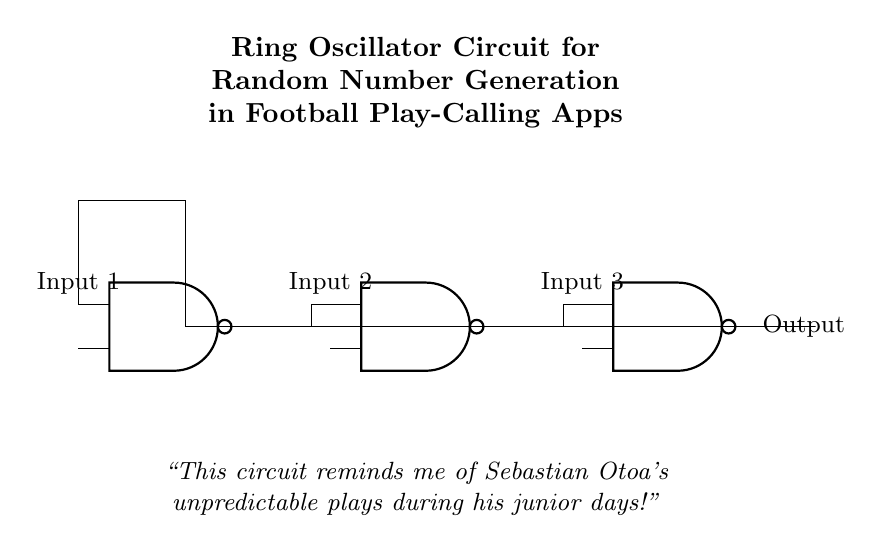What type of gates are used in this circuit? The circuit diagram shows three NAND gates, which are identified by the NAND port labels.
Answer: NAND gates How many inputs do the gates have? Each NAND gate in the circuit has two inputs, indicated by the design of the gates and their input labels.
Answer: Two inputs What is the output of the ring oscillator? The output is taken from the last NAND gate in the series, as shown by the output label next to it.
Answer: Output What is the purpose of this circuit? The circuit is designed for generating random number sequences, as stated in the title of the diagram.
Answer: Random number generation How does feedback work in this ring oscillator? Feedback occurs when the output of the last NAND gate is connected back to the input of the first NAND gate, creating a loop that allows oscillation.
Answer: Feedback loop Why are NAND gates chosen for oscillation? NAND gates are versatile and efficient for constructing oscillators, as they allow for the creation of feedback loops that generate square waves.
Answer: Versatile efficiency What aspect of Sebastian Otoa does the circuit remind the coach of? The circuit’s unpredictability in generating random sequences relates to Otoa's unpredictable play style during his junior days.
Answer: Unpredictable plays 